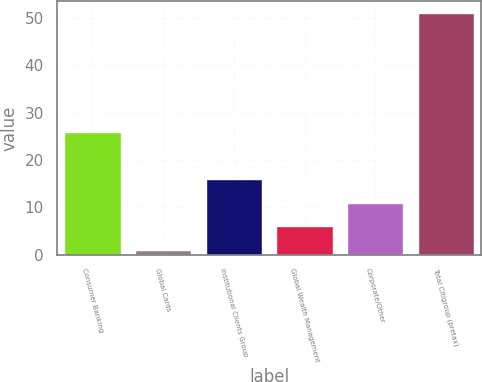Convert chart. <chart><loc_0><loc_0><loc_500><loc_500><bar_chart><fcel>Consumer Banking<fcel>Global Cards<fcel>Institutional Clients Group<fcel>Global Wealth Management<fcel>Corporate/Other<fcel>Total Citigroup (pretax)<nl><fcel>26<fcel>1<fcel>16<fcel>6<fcel>11<fcel>51<nl></chart> 